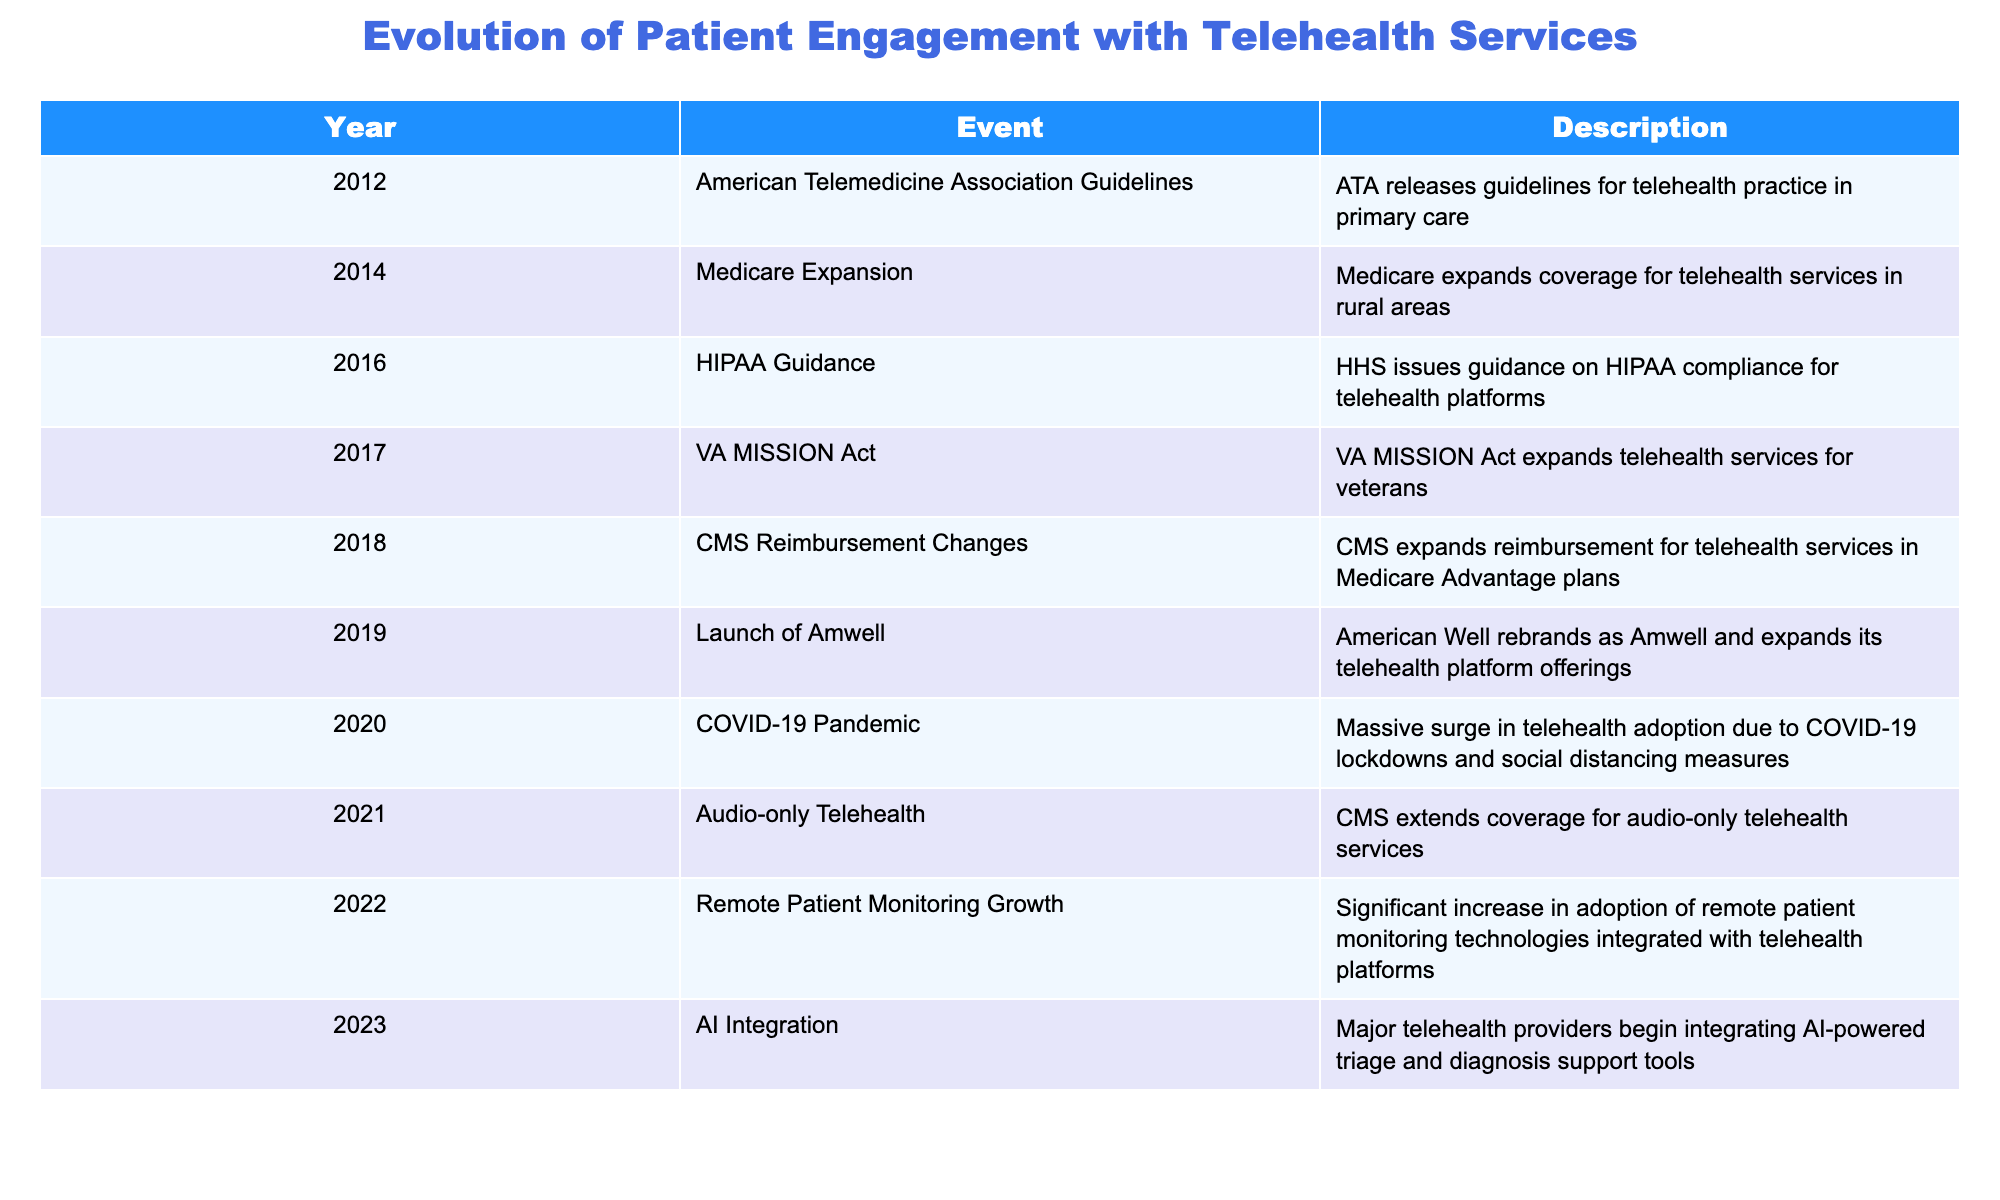What year did the American Telemedicine Association release guidelines for telehealth practice? The table shows that the American Telemedicine Association released guidelines for telehealth practice in the year 2012.
Answer: 2012 Which event marks the expansion of Medicare coverage for telehealth services? According to the table, Medicare expanded coverage for telehealth services in rural areas in 2014.
Answer: 2014 Is there a recorded event mentioning the increase in remote patient monitoring technologies? Yes, the table indicates that there was a significant increase in the adoption of remote patient monitoring technologies integrated with telehealth platforms in 2022.
Answer: Yes What is the difference in years between the launch of Amwell and the integration of AI in telehealth services? Amwell was launched in 2019, while AI integration in telehealth services occurred in 2023. The difference is 2023 - 2019 = 4 years.
Answer: 4 years Did the COVID-19 pandemic serve as a catalyst for the adoption of telehealth? Yes, the table indicates that there was a massive surge in telehealth adoption due to the COVID-19 pandemic in 2020 as a result of lockdowns and social distancing measures.
Answer: Yes What was the significance of the VA MISSION Act in 2017 concerning telehealth? The table states that the VA MISSION Act expanded telehealth services specifically for veterans, indicating a focus on improving access to care for this demographic in 2017.
Answer: Expanded telehealth services for veterans What trend in telehealth services can be deduced from the events listed from 2012 to 2023? By reviewing the events from the table, it can be seen that there has been a progressive expansion of telehealth services, starting with guidelines and growing to include coverage expansions, regulatory guidance, technological integration, and increased adoption, particularly highlighted by the COVID-19 pandemic in 2020.
Answer: Progressive expansion of telehealth services In which year did CMS extend coverage for audio-only telehealth services? The table specifies that CMS extended coverage for audio-only telehealth services in 2021.
Answer: 2021 What percentage of events related to telehealth adoption occurred during or after the COVID-19 pandemic? The events primarily associated with the pandemic or after include the event from 2020 (COVID-19 pandemic), 2021 (audio-only telehealth), 2022 (remote patient monitoring growth), and 2023 (AI integration), totaling 4 out of 11 events listed. Therefore, the percentage is (4/11) * 100 ≈ 36.36%.
Answer: Approximately 36.36% 